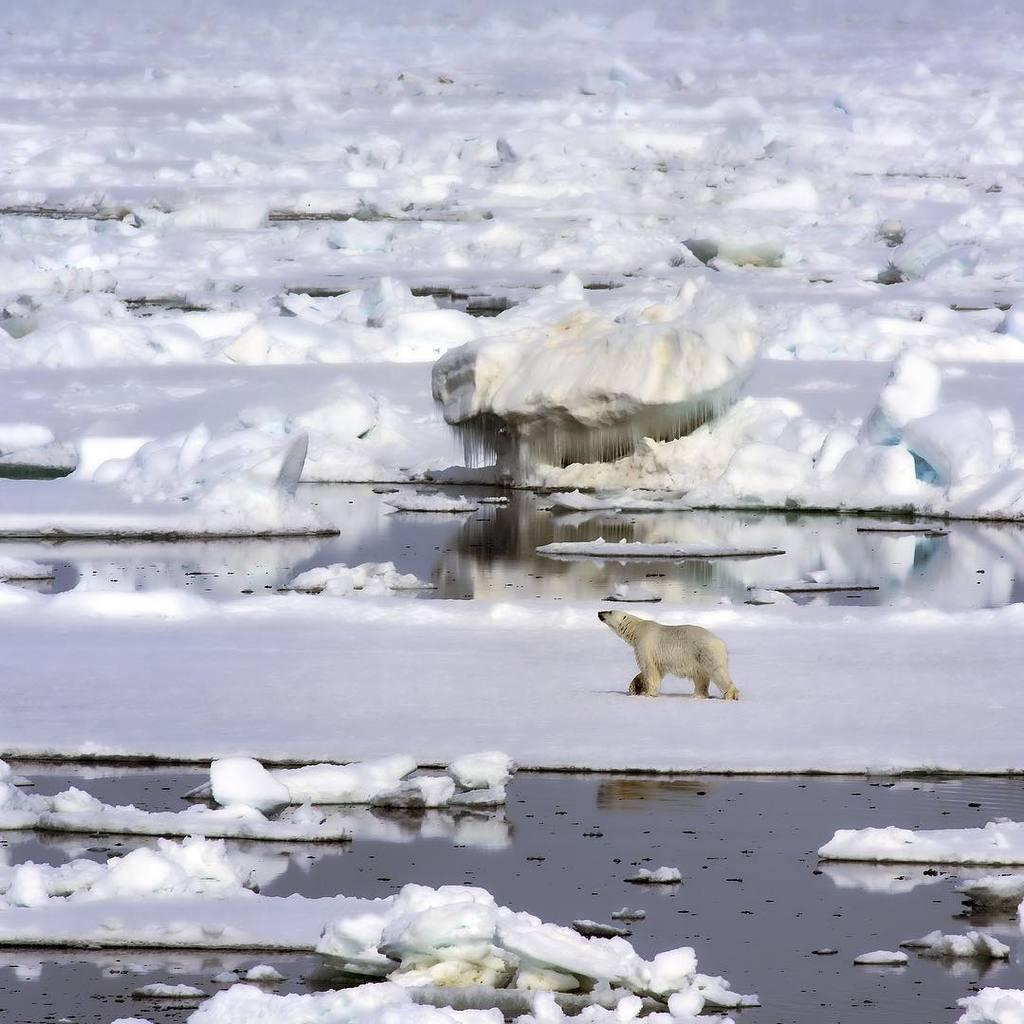What is covering the floor in the image? There is snow on the floor in the image. Can you describe the animal visible in the image? Unfortunately, the facts provided do not give any details about the animal, so we cannot describe it. What type of lamp is hanging from the ceiling in the image? There is no mention of a lamp or ceiling in the provided facts, so we cannot answer this question. 